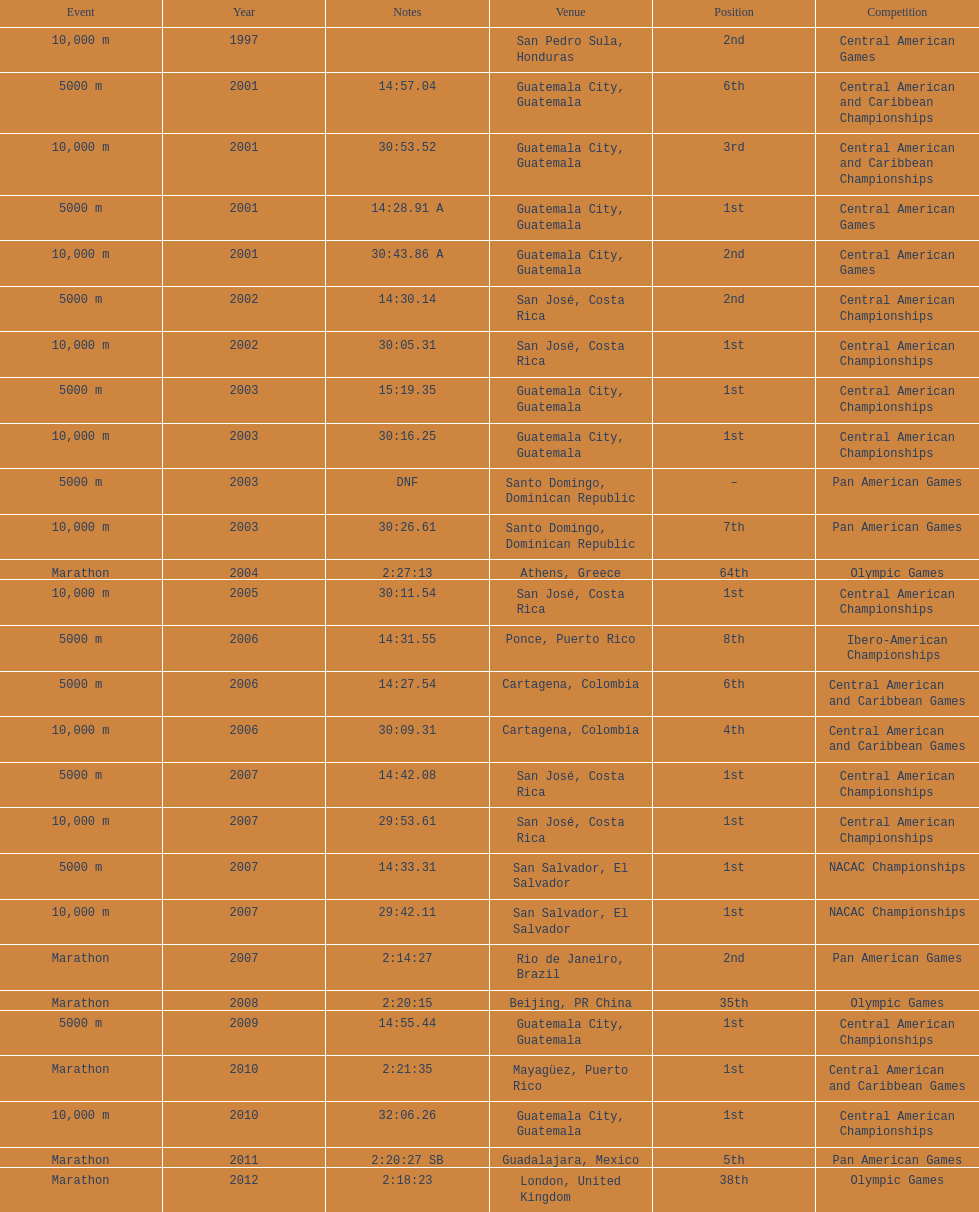Which of each game in 2007 was in the 2nd position? Pan American Games. 